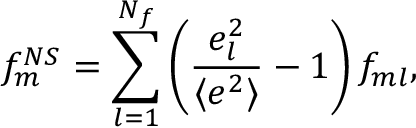<formula> <loc_0><loc_0><loc_500><loc_500>f _ { m } ^ { N S } = \sum _ { l = 1 } ^ { N _ { f } } \left ( { \frac { e _ { l } ^ { 2 } } { \langle e ^ { 2 } \rangle } } - 1 \right ) f _ { m l } ,</formula> 